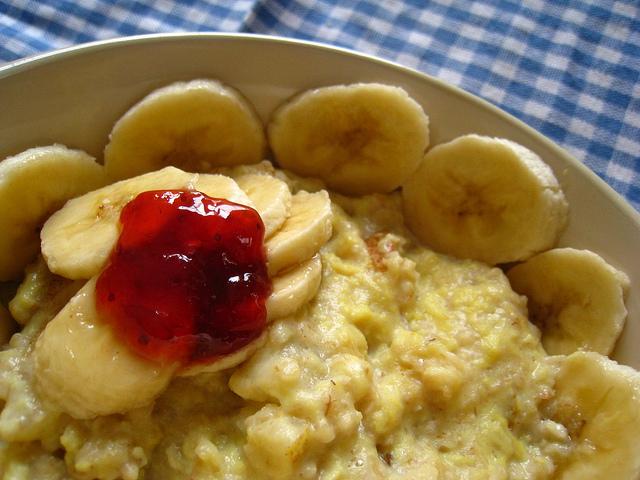What kind of fruit is in the bowl?
Short answer required. Banana. Would this be a healthy breakfast?
Write a very short answer. Yes. Do you like bananas?
Concise answer only. Yes. 